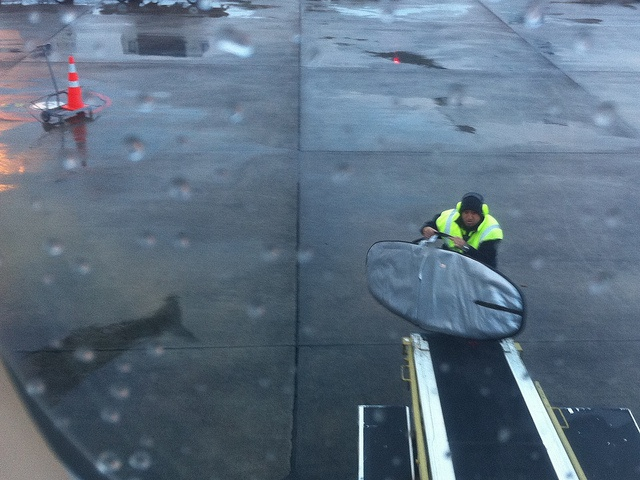Describe the objects in this image and their specific colors. I can see surfboard in blue and gray tones and people in blue, black, gray, and lightgreen tones in this image. 